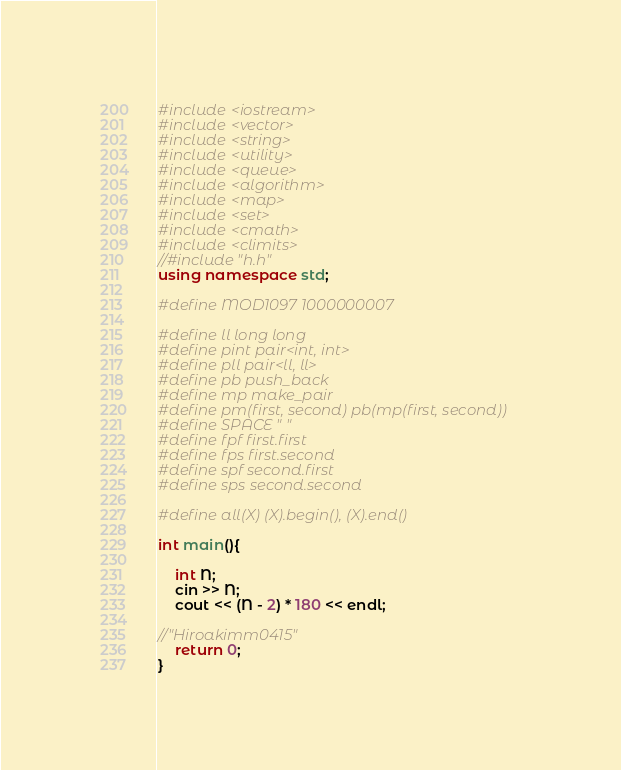Convert code to text. <code><loc_0><loc_0><loc_500><loc_500><_C++_>#include <iostream>
#include <vector>
#include <string>
#include <utility>
#include <queue>
#include <algorithm>
#include <map>
#include <set>
#include <cmath>
#include <climits>
//#include "h.h"
using namespace std;

#define MOD1097 1000000007

#define ll long long
#define pint pair<int, int>
#define pll pair<ll, ll>
#define pb push_back
#define mp make_pair
#define pm(first, second) pb(mp(first, second))
#define SPACE " "
#define fpf first.first
#define fps first.second
#define spf second.first
#define sps second.second

#define all(X) (X).begin(), (X).end()

int main(){

	int N;
	cin >> N;
	cout << (N - 2) * 180 << endl;

//"Hiroakimm0415"
	return 0;
}</code> 